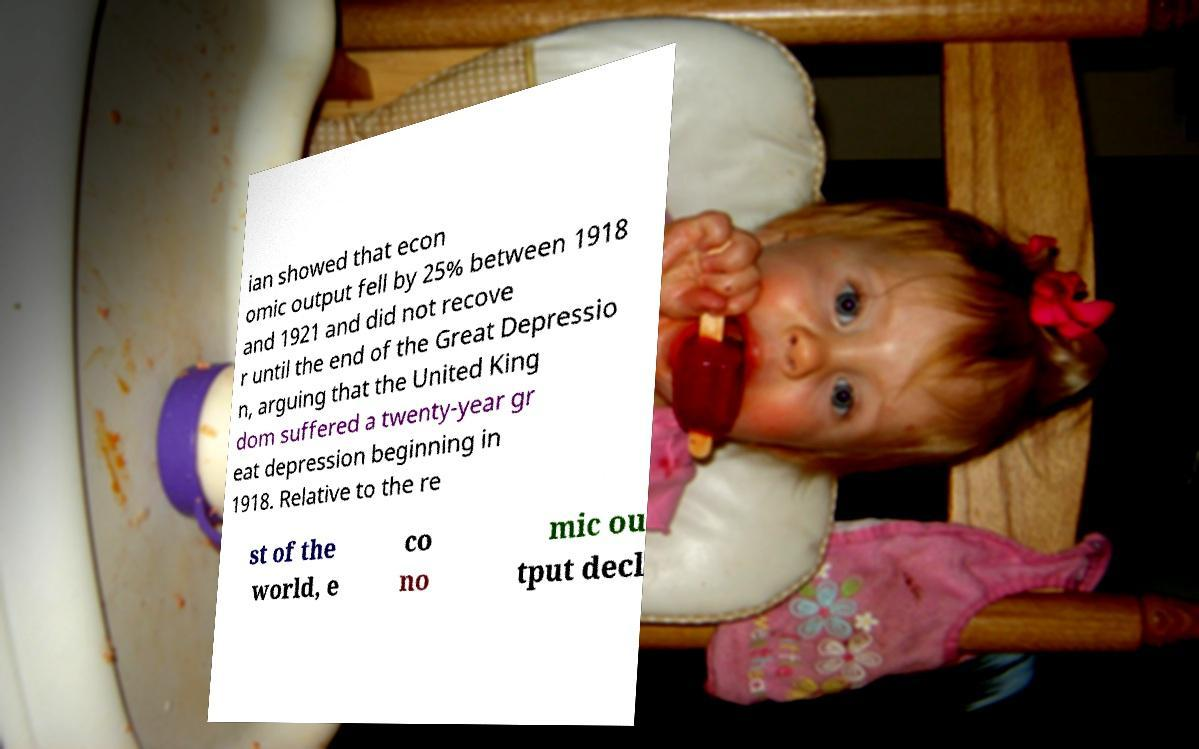For documentation purposes, I need the text within this image transcribed. Could you provide that? ian showed that econ omic output fell by 25% between 1918 and 1921 and did not recove r until the end of the Great Depressio n, arguing that the United King dom suffered a twenty-year gr eat depression beginning in 1918. Relative to the re st of the world, e co no mic ou tput decl 